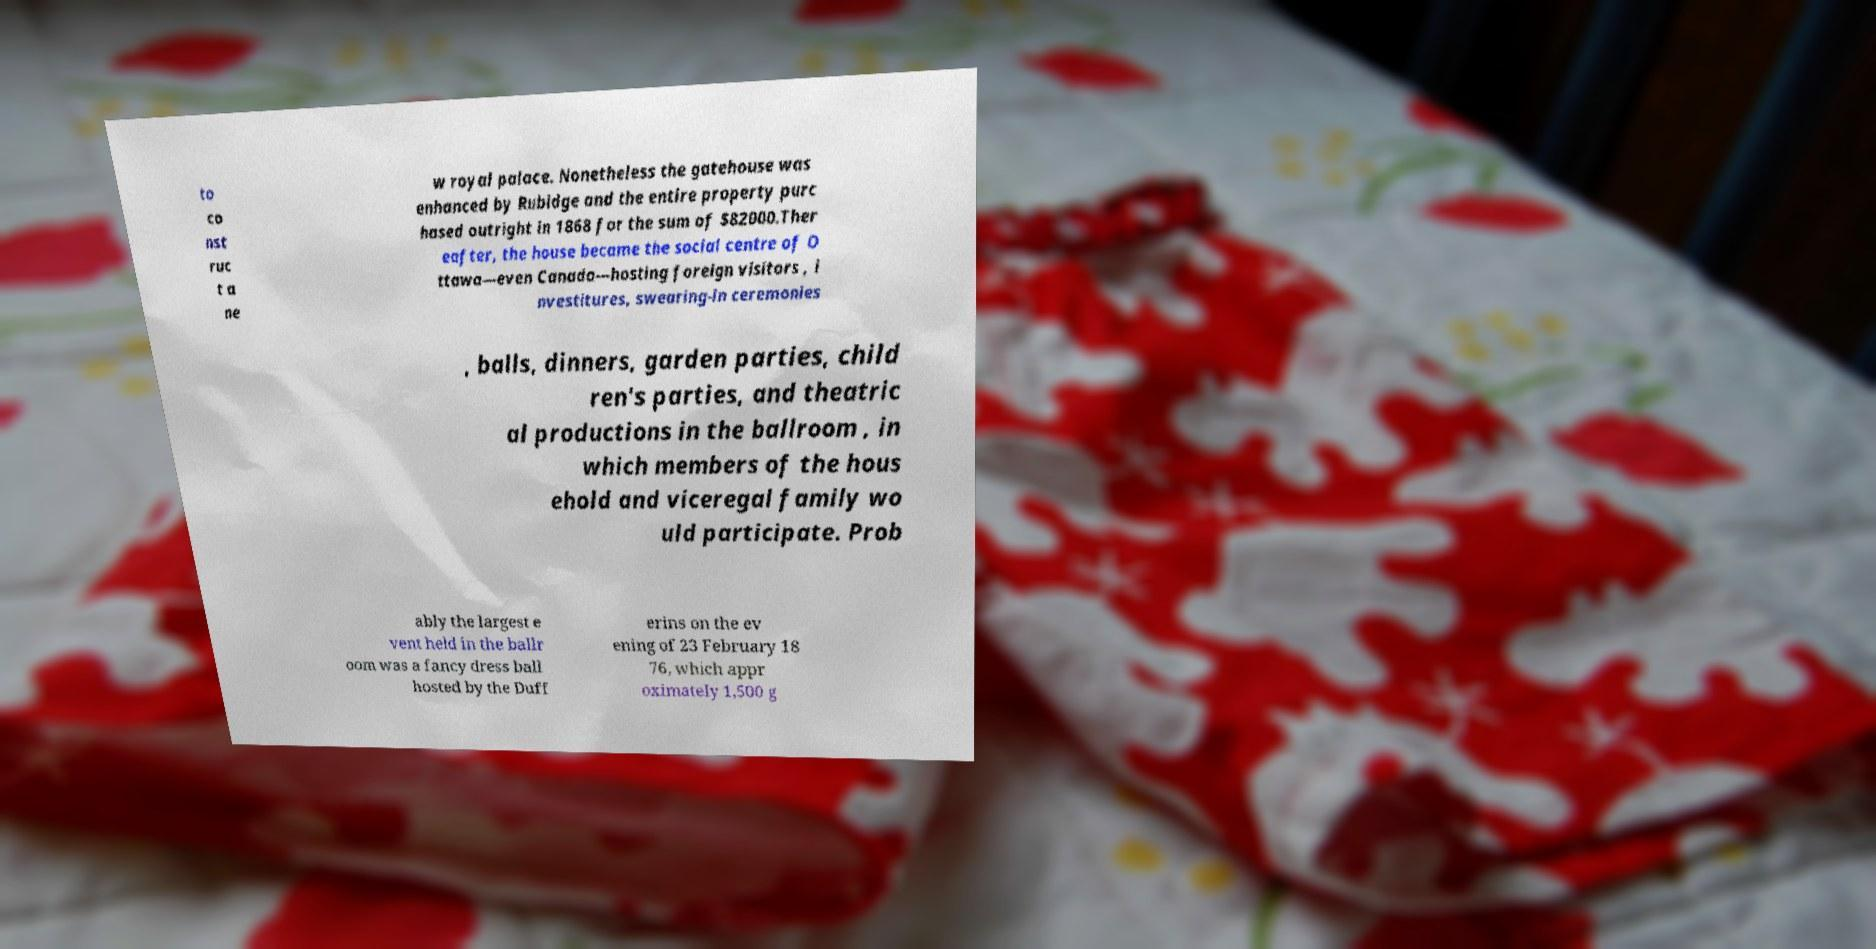Can you read and provide the text displayed in the image?This photo seems to have some interesting text. Can you extract and type it out for me? to co nst ruc t a ne w royal palace. Nonetheless the gatehouse was enhanced by Rubidge and the entire property purc hased outright in 1868 for the sum of $82000.Ther eafter, the house became the social centre of O ttawa—even Canada—hosting foreign visitors , i nvestitures, swearing-in ceremonies , balls, dinners, garden parties, child ren's parties, and theatric al productions in the ballroom , in which members of the hous ehold and viceregal family wo uld participate. Prob ably the largest e vent held in the ballr oom was a fancy dress ball hosted by the Duff erins on the ev ening of 23 February 18 76, which appr oximately 1,500 g 